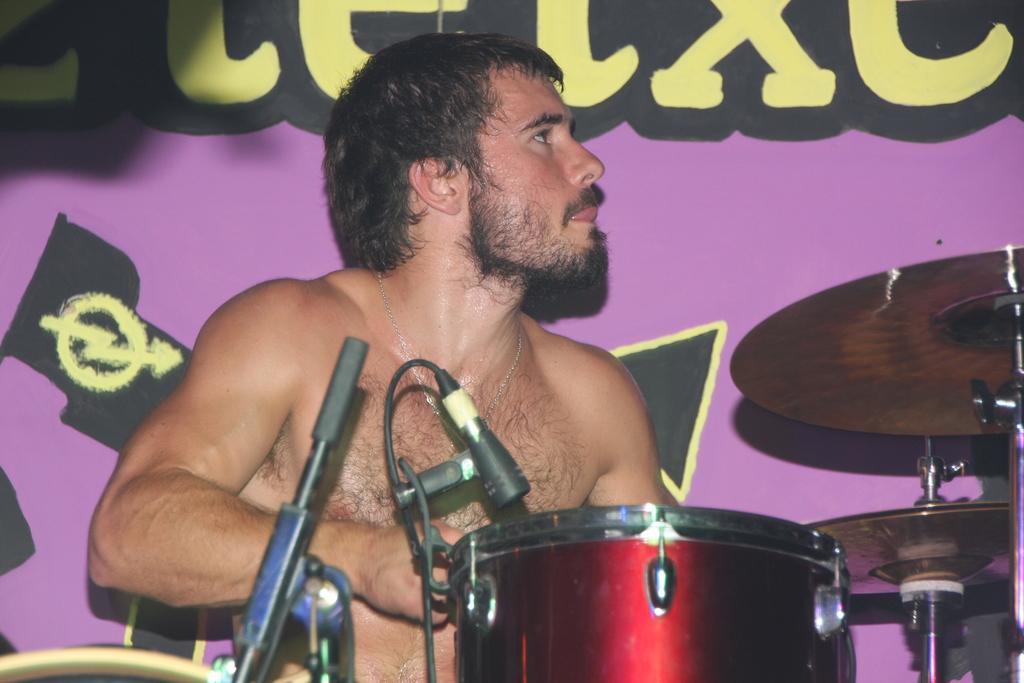How would you summarize this image in a sentence or two? This man is looking right side and playing this musical instruments. 